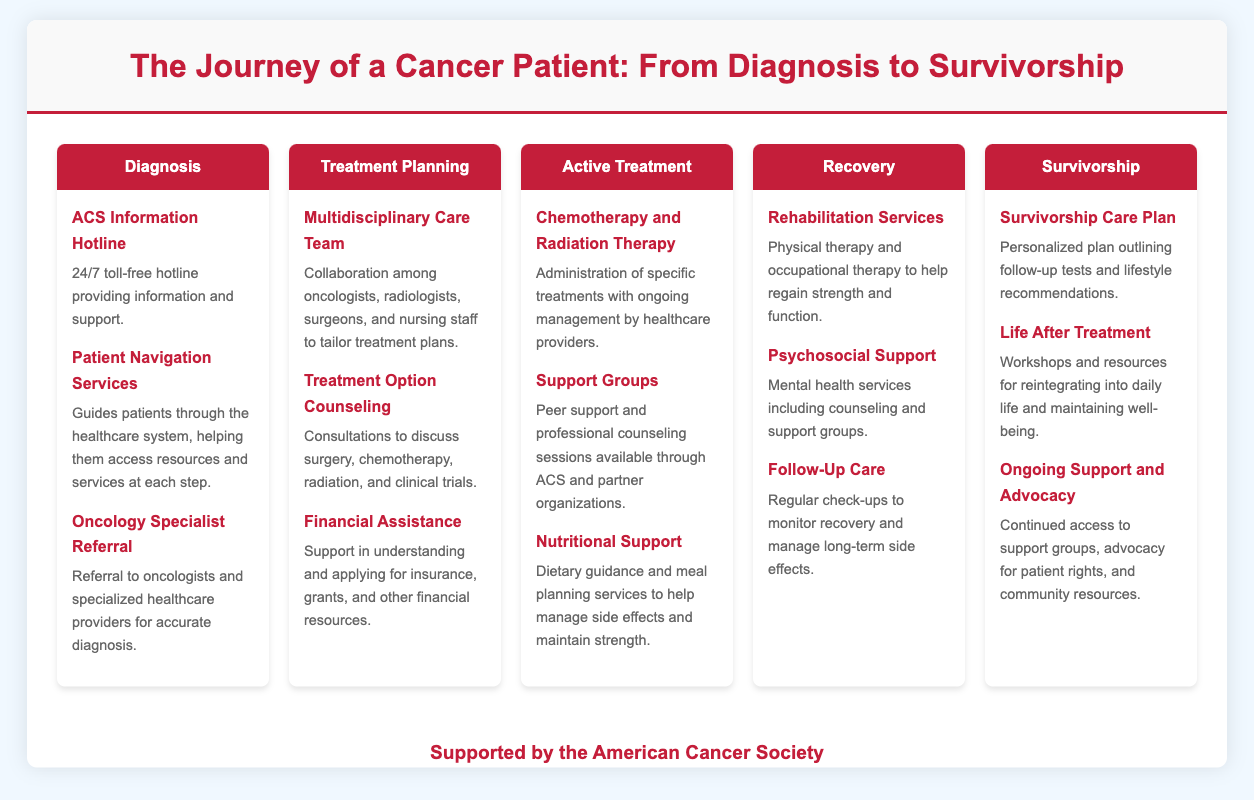What is the first stage of the cancer patient's journey? The first stage listed in the infographic is "Diagnosis," which indicates the initial step in the cancer patient's journey.
Answer: Diagnosis How many support services are listed under Treatment Planning? The infographic specifies three support services provided during the Treatment Planning stage, reflecting the range of assistance available at that time.
Answer: 3 What kind of support is offered during the Active Treatment stage? The specific types of support during Active Treatment include chemotherapy, support groups, and nutritional guidance, highlighting a comprehensive approach to patient care in this stage.
Answer: Chemotherapy and Radiation Therapy, Support Groups, Nutritional Support What type of services are included in Recovery? The Recovery stage includes Rehabilitation Services, Psychosocial Support, and Follow-Up Care, indicating a focus on both physical and mental health services.
Answer: Rehabilitation Services, Psychosocial Support, Follow-Up Care What is provided in Survivorship? Survivorship includes a Survivorship Care Plan, resources for Life After Treatment, and Ongoing Support and Advocacy, reflecting an ongoing commitment to patient care beyond active treatment.
Answer: Survivorship Care Plan, Life After Treatment, Ongoing Support and Advocacy What does the ACS Information Hotline offer? The ACS Information Hotline is described as a 24/7 toll-free hotline, indicating its availability for immediate support and information to patients.
Answer: 24/7 toll-free hotline providing information and support What kind of assistance is available for financial concerns? Financial Assistance services help patients understand and apply for various financial resources, reflecting the necessity of addressing financial challenges during treatment.
Answer: Financial Assistance Which professionals collaborate in the Multidisciplinary Care Team? The infographic states that oncologists, radiologists, surgeons, and nursing staff collaborate, showcasing the interdisciplinary approach necessary for effective cancer treatment.
Answer: Oncologists, radiologists, surgeons, and nursing staff 